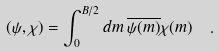<formula> <loc_0><loc_0><loc_500><loc_500>\left ( \psi , \chi \right ) = \int _ { 0 } ^ { B / 2 } d { m } \, { \overline { \psi ( { m } ) } } \chi ( { m } ) \ \ .</formula> 